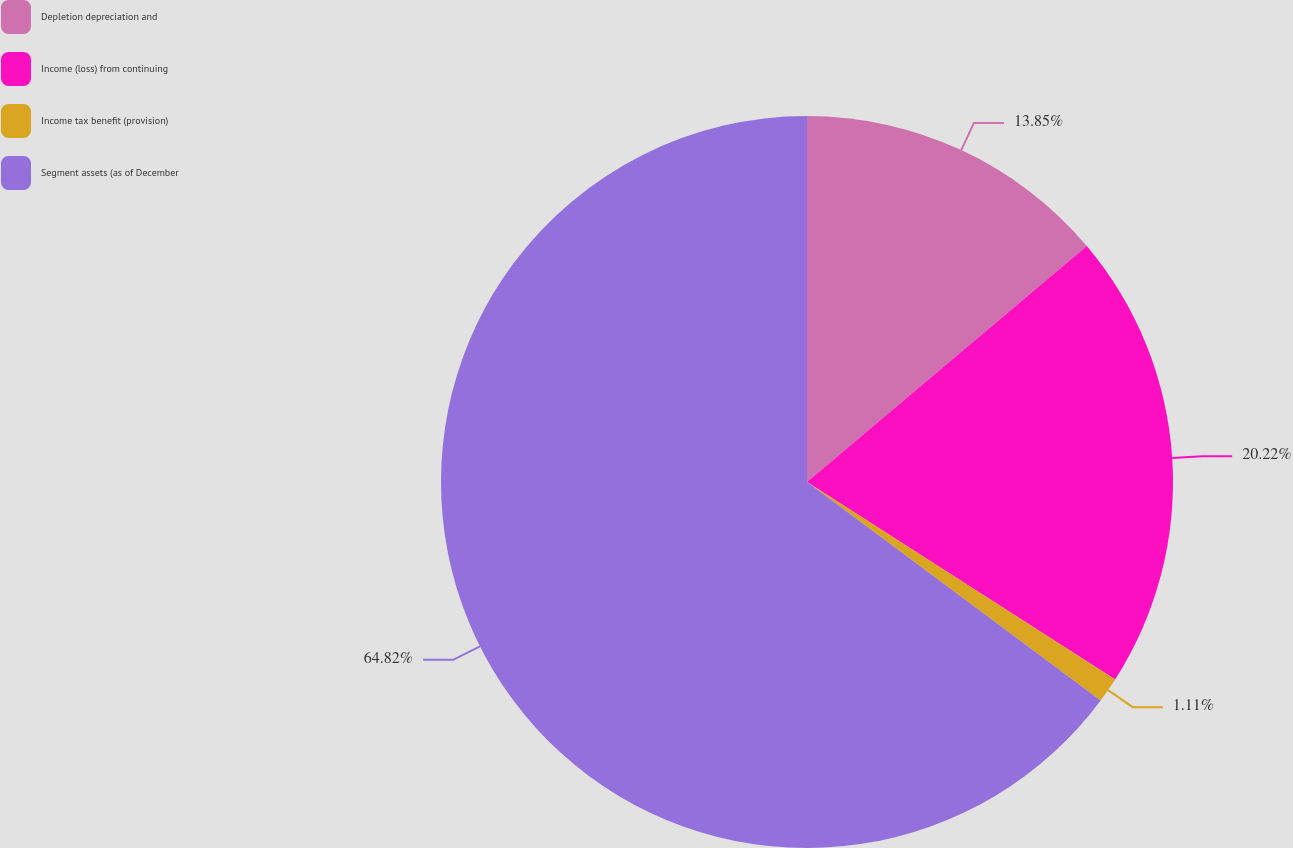Convert chart. <chart><loc_0><loc_0><loc_500><loc_500><pie_chart><fcel>Depletion depreciation and<fcel>Income (loss) from continuing<fcel>Income tax benefit (provision)<fcel>Segment assets (as of December<nl><fcel>13.85%<fcel>20.22%<fcel>1.11%<fcel>64.82%<nl></chart> 